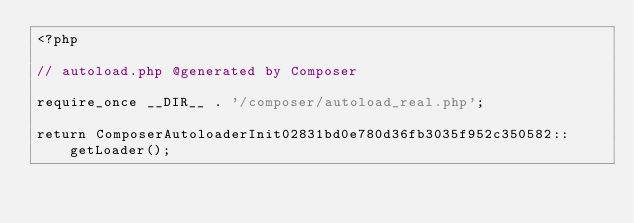<code> <loc_0><loc_0><loc_500><loc_500><_PHP_><?php

// autoload.php @generated by Composer

require_once __DIR__ . '/composer/autoload_real.php';

return ComposerAutoloaderInit02831bd0e780d36fb3035f952c350582::getLoader();
</code> 